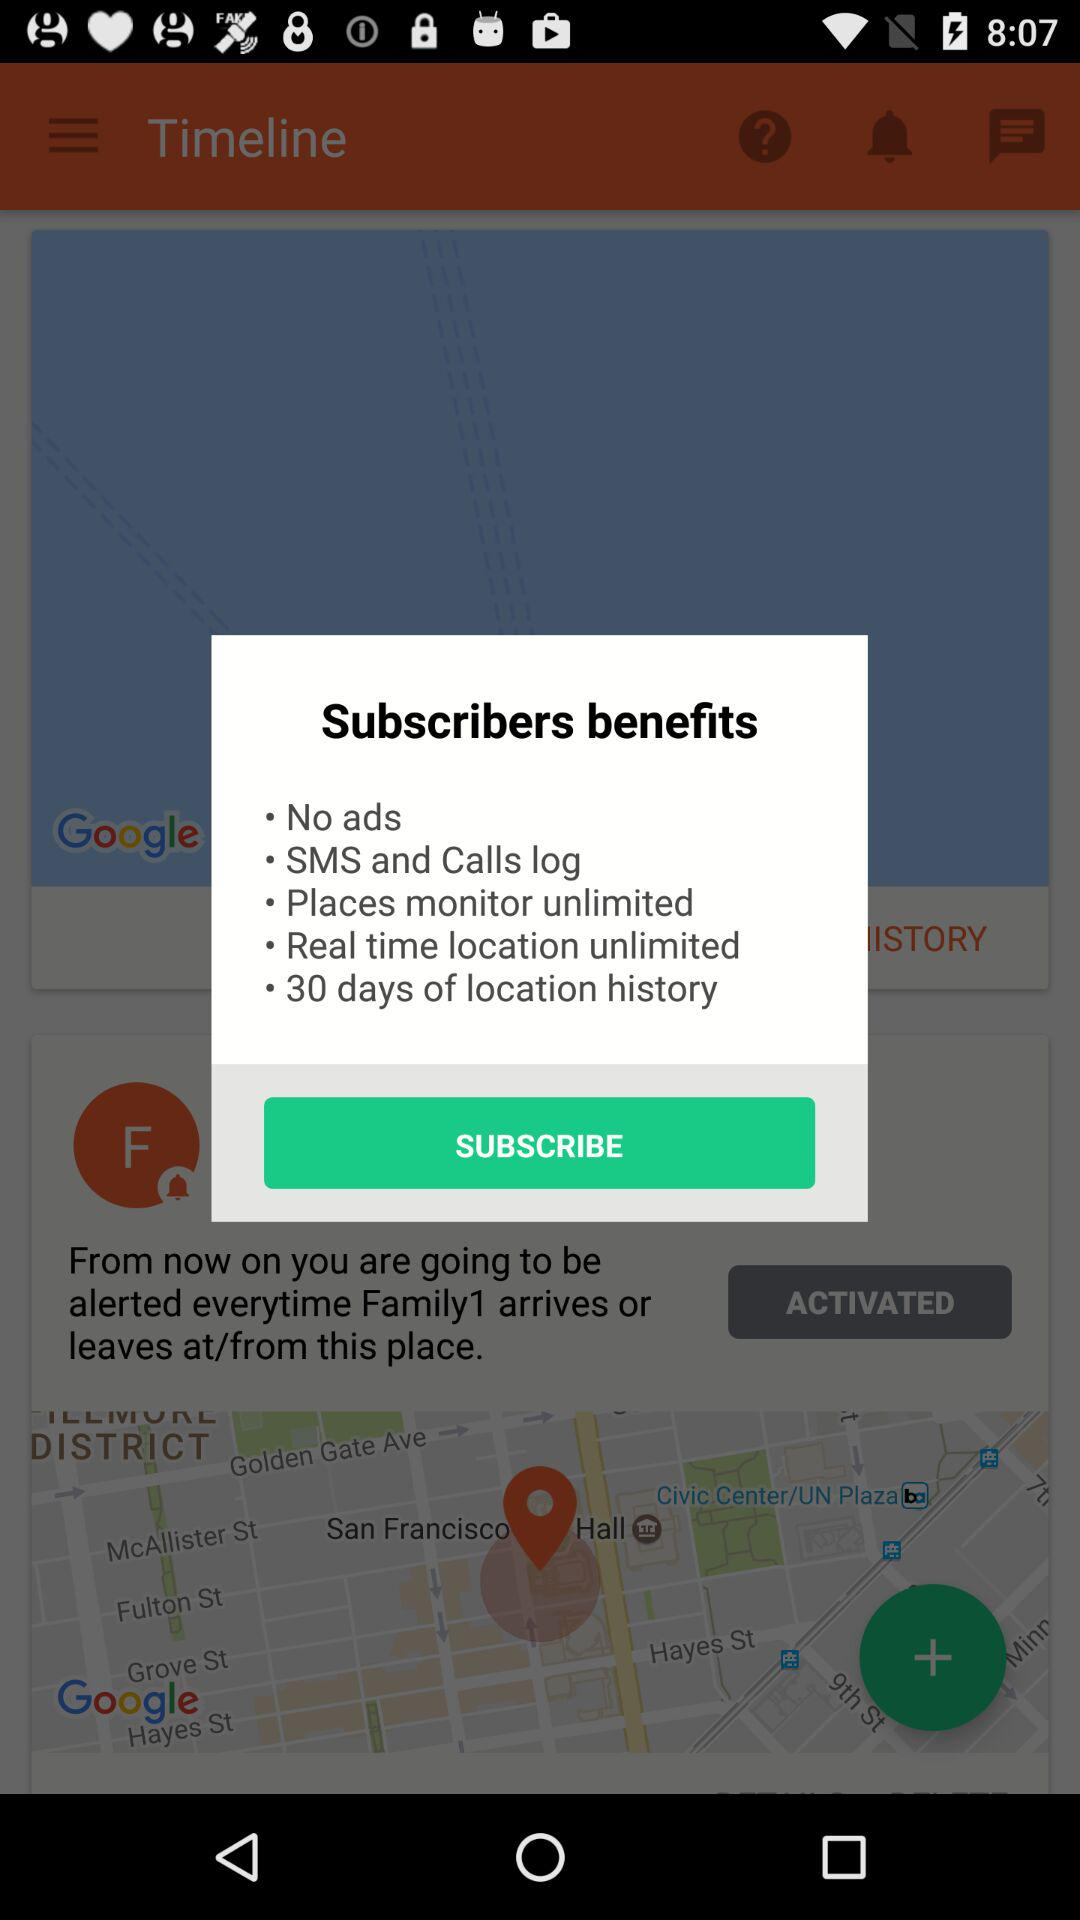What are the subscribers' benefits? The subscribers' benefits are "No ads", "SMS and Calls log", "Places monitor unlimited", "Real time location unlimited" and "30 days of location history". 